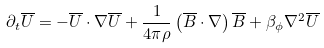Convert formula to latex. <formula><loc_0><loc_0><loc_500><loc_500>\partial _ { t } \overline { U } = - \overline { U } \cdot \nabla \overline { U } + \frac { 1 } { 4 \pi \rho } \left ( \overline { B } \cdot \nabla \right ) \overline { B } + \beta _ { \phi } \nabla ^ { 2 } \overline { U }</formula> 